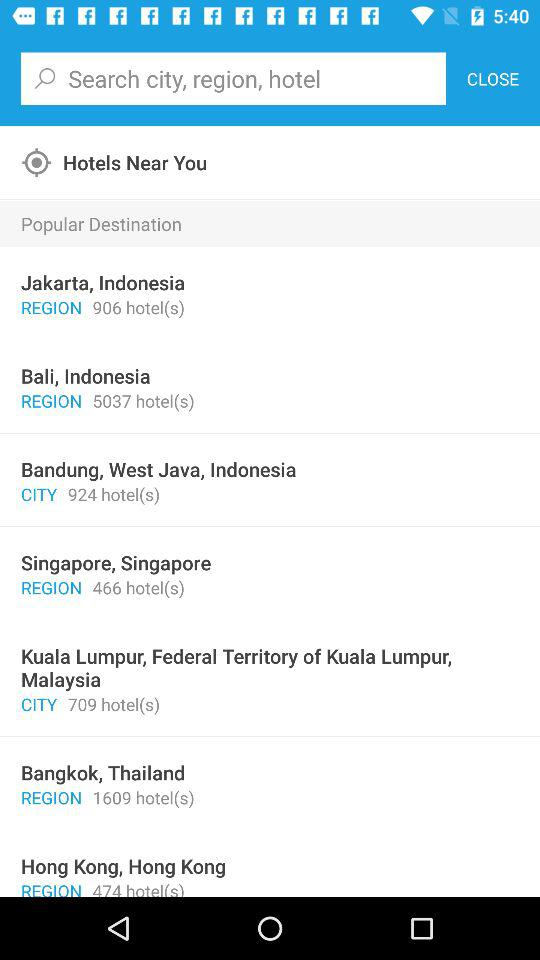How many hotels are in Jakarta, Indonesia? There are 906 hotels. 